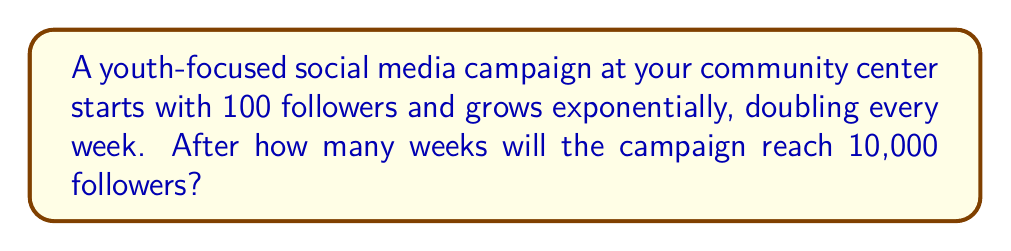Provide a solution to this math problem. Let's approach this step-by-step:

1) We can model this growth with the exponential function:

   $$ f(t) = 100 \cdot 2^t $$

   Where $f(t)$ is the number of followers after $t$ weeks.

2) We want to find $t$ when $f(t) = 10,000$. So, we set up the equation:

   $$ 10,000 = 100 \cdot 2^t $$

3) Divide both sides by 100:

   $$ 100 = 2^t $$

4) Take the logarithm (base 2) of both sides:

   $$ \log_2(100) = \log_2(2^t) $$

5) Using the logarithm property $\log_a(a^x) = x$, we get:

   $$ \log_2(100) = t $$

6) Calculate $\log_2(100)$:

   $$ t = \frac{\log(100)}{\log(2)} \approx 6.64386 $$

7) Since we can only have whole weeks, we need to round up to the next integer.
Answer: 7 weeks 